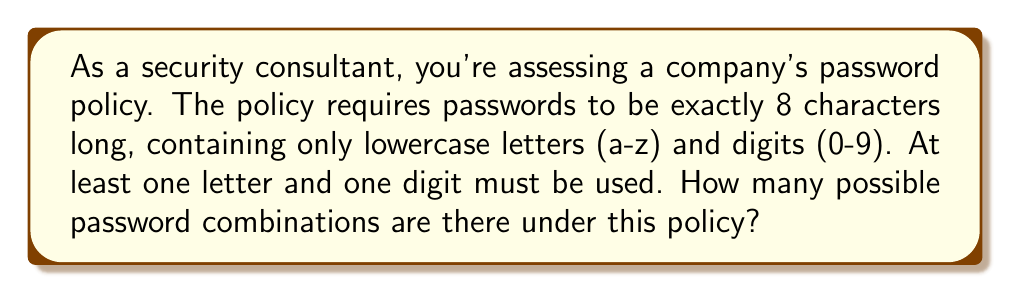Can you answer this question? Let's approach this step-by-step:

1) First, we need to calculate the total number of characters available:
   - 26 lowercase letters
   - 10 digits
   Total: 26 + 10 = 36 characters

2) If there were no restrictions, the total number of combinations would be:
   $36^8$ (36 choices for each of the 8 positions)

3) However, we need to subtract the combinations that don't meet the policy:
   a) Passwords with only letters: $26^8$
   b) Passwords with only digits: $10^8$

4) Therefore, the number of valid passwords is:
   $36^8 - 26^8 - 10^8$

5) Let's calculate this:
   $36^8 = 2,821,109,907,456$
   $26^8 = 208,827,064,576$
   $10^8 = 100,000,000$

6) Final calculation:
   $2,821,109,907,456 - 208,827,064,576 - 100,000,000 = 2,612,182,842,880$

Thus, there are 2,612,182,842,880 possible password combinations under this policy.
Answer: 2,612,182,842,880 